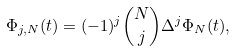Convert formula to latex. <formula><loc_0><loc_0><loc_500><loc_500>\Phi _ { j , N } ( t ) = ( - 1 ) ^ { j } \binom { N } { j } \Delta ^ { j } \Phi _ { N } ( t ) ,</formula> 